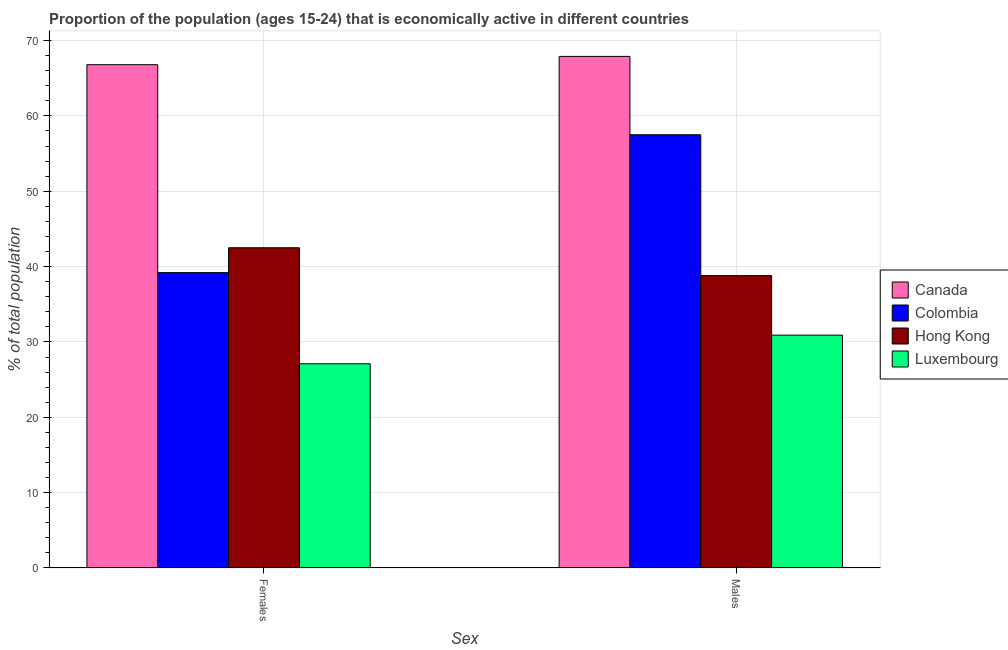How many groups of bars are there?
Your answer should be very brief. 2. What is the label of the 2nd group of bars from the left?
Provide a succinct answer. Males. What is the percentage of economically active male population in Hong Kong?
Provide a succinct answer. 38.8. Across all countries, what is the maximum percentage of economically active male population?
Ensure brevity in your answer.  67.9. Across all countries, what is the minimum percentage of economically active female population?
Give a very brief answer. 27.1. In which country was the percentage of economically active male population minimum?
Ensure brevity in your answer.  Luxembourg. What is the total percentage of economically active male population in the graph?
Make the answer very short. 195.1. What is the difference between the percentage of economically active female population in Canada and that in Luxembourg?
Your answer should be compact. 39.7. What is the difference between the percentage of economically active male population in Hong Kong and the percentage of economically active female population in Luxembourg?
Provide a short and direct response. 11.7. What is the average percentage of economically active female population per country?
Provide a short and direct response. 43.9. What is the difference between the percentage of economically active female population and percentage of economically active male population in Luxembourg?
Keep it short and to the point. -3.8. In how many countries, is the percentage of economically active male population greater than 28 %?
Your answer should be very brief. 4. What is the ratio of the percentage of economically active male population in Luxembourg to that in Hong Kong?
Offer a very short reply. 0.8. Is the percentage of economically active male population in Hong Kong less than that in Colombia?
Your response must be concise. Yes. In how many countries, is the percentage of economically active male population greater than the average percentage of economically active male population taken over all countries?
Give a very brief answer. 2. What does the 2nd bar from the left in Males represents?
Provide a short and direct response. Colombia. What does the 4th bar from the right in Females represents?
Give a very brief answer. Canada. Does the graph contain grids?
Give a very brief answer. Yes. Where does the legend appear in the graph?
Provide a short and direct response. Center right. How many legend labels are there?
Offer a very short reply. 4. How are the legend labels stacked?
Your answer should be compact. Vertical. What is the title of the graph?
Provide a short and direct response. Proportion of the population (ages 15-24) that is economically active in different countries. Does "Austria" appear as one of the legend labels in the graph?
Provide a succinct answer. No. What is the label or title of the X-axis?
Provide a short and direct response. Sex. What is the label or title of the Y-axis?
Offer a very short reply. % of total population. What is the % of total population in Canada in Females?
Offer a terse response. 66.8. What is the % of total population of Colombia in Females?
Ensure brevity in your answer.  39.2. What is the % of total population in Hong Kong in Females?
Make the answer very short. 42.5. What is the % of total population of Luxembourg in Females?
Give a very brief answer. 27.1. What is the % of total population in Canada in Males?
Your answer should be very brief. 67.9. What is the % of total population of Colombia in Males?
Your answer should be very brief. 57.5. What is the % of total population of Hong Kong in Males?
Your response must be concise. 38.8. What is the % of total population in Luxembourg in Males?
Make the answer very short. 30.9. Across all Sex, what is the maximum % of total population in Canada?
Give a very brief answer. 67.9. Across all Sex, what is the maximum % of total population of Colombia?
Ensure brevity in your answer.  57.5. Across all Sex, what is the maximum % of total population of Hong Kong?
Offer a very short reply. 42.5. Across all Sex, what is the maximum % of total population of Luxembourg?
Your response must be concise. 30.9. Across all Sex, what is the minimum % of total population in Canada?
Keep it short and to the point. 66.8. Across all Sex, what is the minimum % of total population of Colombia?
Make the answer very short. 39.2. Across all Sex, what is the minimum % of total population of Hong Kong?
Offer a terse response. 38.8. Across all Sex, what is the minimum % of total population in Luxembourg?
Give a very brief answer. 27.1. What is the total % of total population of Canada in the graph?
Ensure brevity in your answer.  134.7. What is the total % of total population of Colombia in the graph?
Your answer should be compact. 96.7. What is the total % of total population of Hong Kong in the graph?
Provide a short and direct response. 81.3. What is the total % of total population in Luxembourg in the graph?
Provide a succinct answer. 58. What is the difference between the % of total population of Colombia in Females and that in Males?
Your response must be concise. -18.3. What is the difference between the % of total population of Canada in Females and the % of total population of Colombia in Males?
Offer a very short reply. 9.3. What is the difference between the % of total population in Canada in Females and the % of total population in Hong Kong in Males?
Your answer should be very brief. 28. What is the difference between the % of total population in Canada in Females and the % of total population in Luxembourg in Males?
Give a very brief answer. 35.9. What is the difference between the % of total population of Colombia in Females and the % of total population of Luxembourg in Males?
Offer a terse response. 8.3. What is the average % of total population of Canada per Sex?
Offer a very short reply. 67.35. What is the average % of total population in Colombia per Sex?
Offer a terse response. 48.35. What is the average % of total population in Hong Kong per Sex?
Your answer should be very brief. 40.65. What is the average % of total population of Luxembourg per Sex?
Your answer should be compact. 29. What is the difference between the % of total population of Canada and % of total population of Colombia in Females?
Ensure brevity in your answer.  27.6. What is the difference between the % of total population of Canada and % of total population of Hong Kong in Females?
Your answer should be very brief. 24.3. What is the difference between the % of total population of Canada and % of total population of Luxembourg in Females?
Your answer should be compact. 39.7. What is the difference between the % of total population of Colombia and % of total population of Hong Kong in Females?
Give a very brief answer. -3.3. What is the difference between the % of total population in Canada and % of total population in Colombia in Males?
Your answer should be compact. 10.4. What is the difference between the % of total population in Canada and % of total population in Hong Kong in Males?
Offer a very short reply. 29.1. What is the difference between the % of total population in Canada and % of total population in Luxembourg in Males?
Give a very brief answer. 37. What is the difference between the % of total population in Colombia and % of total population in Hong Kong in Males?
Your answer should be very brief. 18.7. What is the difference between the % of total population in Colombia and % of total population in Luxembourg in Males?
Your response must be concise. 26.6. What is the ratio of the % of total population in Canada in Females to that in Males?
Your response must be concise. 0.98. What is the ratio of the % of total population of Colombia in Females to that in Males?
Give a very brief answer. 0.68. What is the ratio of the % of total population of Hong Kong in Females to that in Males?
Offer a very short reply. 1.1. What is the ratio of the % of total population of Luxembourg in Females to that in Males?
Give a very brief answer. 0.88. What is the difference between the highest and the second highest % of total population in Canada?
Your response must be concise. 1.1. What is the difference between the highest and the second highest % of total population in Luxembourg?
Provide a short and direct response. 3.8. What is the difference between the highest and the lowest % of total population of Luxembourg?
Your answer should be very brief. 3.8. 